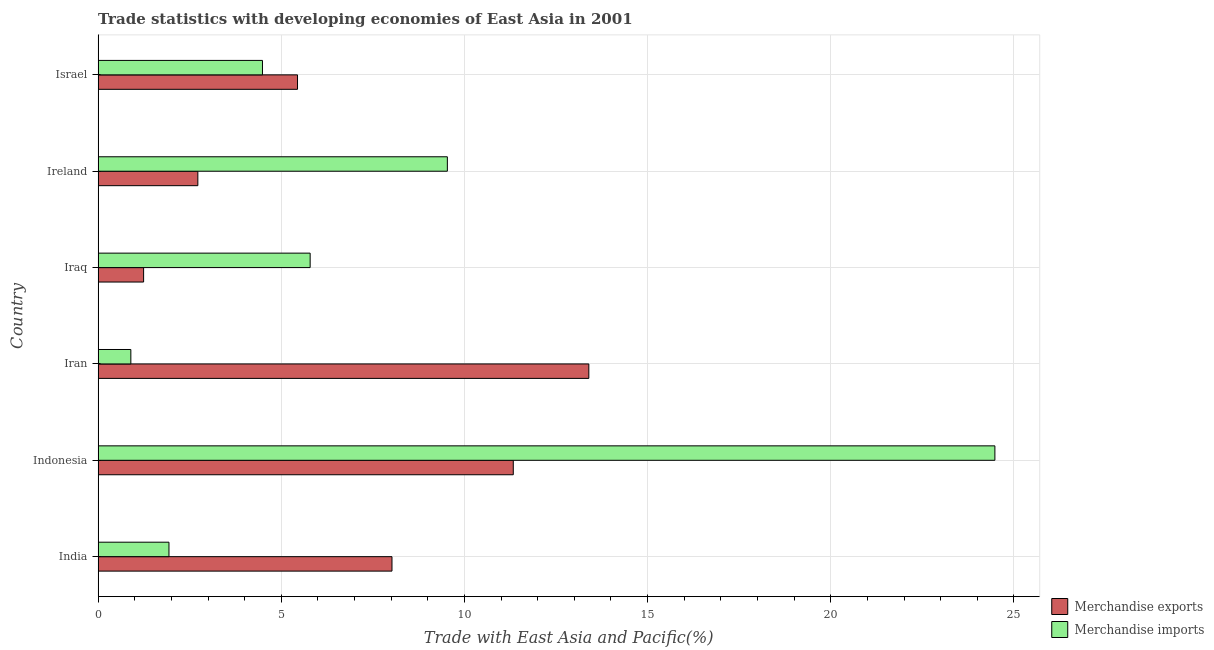How many different coloured bars are there?
Keep it short and to the point. 2. Are the number of bars per tick equal to the number of legend labels?
Offer a terse response. Yes. Are the number of bars on each tick of the Y-axis equal?
Provide a short and direct response. Yes. How many bars are there on the 6th tick from the bottom?
Provide a succinct answer. 2. What is the merchandise exports in Indonesia?
Your answer should be compact. 11.33. Across all countries, what is the maximum merchandise imports?
Offer a terse response. 24.48. Across all countries, what is the minimum merchandise exports?
Your response must be concise. 1.24. In which country was the merchandise exports minimum?
Your answer should be very brief. Iraq. What is the total merchandise exports in the graph?
Your response must be concise. 42.16. What is the difference between the merchandise imports in India and that in Indonesia?
Give a very brief answer. -22.55. What is the difference between the merchandise exports in Iraq and the merchandise imports in India?
Your answer should be compact. -0.69. What is the average merchandise exports per country?
Your response must be concise. 7.03. What is the difference between the merchandise exports and merchandise imports in Ireland?
Your response must be concise. -6.81. In how many countries, is the merchandise exports greater than 9 %?
Provide a succinct answer. 2. What is the ratio of the merchandise imports in Iraq to that in Ireland?
Your answer should be compact. 0.61. Is the difference between the merchandise imports in Iran and Israel greater than the difference between the merchandise exports in Iran and Israel?
Offer a terse response. No. What is the difference between the highest and the second highest merchandise imports?
Give a very brief answer. 14.95. What is the difference between the highest and the lowest merchandise exports?
Provide a succinct answer. 12.15. Is the sum of the merchandise exports in Indonesia and Ireland greater than the maximum merchandise imports across all countries?
Your answer should be very brief. No. What does the 2nd bar from the top in Iraq represents?
Keep it short and to the point. Merchandise exports. What does the 2nd bar from the bottom in Iran represents?
Provide a short and direct response. Merchandise imports. Are all the bars in the graph horizontal?
Your response must be concise. Yes. Are the values on the major ticks of X-axis written in scientific E-notation?
Ensure brevity in your answer.  No. Does the graph contain any zero values?
Make the answer very short. No. Does the graph contain grids?
Provide a short and direct response. Yes. Where does the legend appear in the graph?
Your answer should be compact. Bottom right. What is the title of the graph?
Your answer should be compact. Trade statistics with developing economies of East Asia in 2001. Does "current US$" appear as one of the legend labels in the graph?
Keep it short and to the point. No. What is the label or title of the X-axis?
Ensure brevity in your answer.  Trade with East Asia and Pacific(%). What is the Trade with East Asia and Pacific(%) of Merchandise exports in India?
Keep it short and to the point. 8.02. What is the Trade with East Asia and Pacific(%) in Merchandise imports in India?
Give a very brief answer. 1.93. What is the Trade with East Asia and Pacific(%) of Merchandise exports in Indonesia?
Keep it short and to the point. 11.33. What is the Trade with East Asia and Pacific(%) of Merchandise imports in Indonesia?
Your answer should be very brief. 24.48. What is the Trade with East Asia and Pacific(%) of Merchandise exports in Iran?
Your answer should be compact. 13.4. What is the Trade with East Asia and Pacific(%) of Merchandise imports in Iran?
Ensure brevity in your answer.  0.89. What is the Trade with East Asia and Pacific(%) of Merchandise exports in Iraq?
Ensure brevity in your answer.  1.24. What is the Trade with East Asia and Pacific(%) of Merchandise imports in Iraq?
Your answer should be very brief. 5.79. What is the Trade with East Asia and Pacific(%) in Merchandise exports in Ireland?
Offer a very short reply. 2.72. What is the Trade with East Asia and Pacific(%) in Merchandise imports in Ireland?
Your answer should be compact. 9.53. What is the Trade with East Asia and Pacific(%) of Merchandise exports in Israel?
Your answer should be compact. 5.44. What is the Trade with East Asia and Pacific(%) of Merchandise imports in Israel?
Your answer should be compact. 4.49. Across all countries, what is the maximum Trade with East Asia and Pacific(%) of Merchandise exports?
Keep it short and to the point. 13.4. Across all countries, what is the maximum Trade with East Asia and Pacific(%) of Merchandise imports?
Give a very brief answer. 24.48. Across all countries, what is the minimum Trade with East Asia and Pacific(%) of Merchandise exports?
Provide a succinct answer. 1.24. Across all countries, what is the minimum Trade with East Asia and Pacific(%) of Merchandise imports?
Offer a very short reply. 0.89. What is the total Trade with East Asia and Pacific(%) of Merchandise exports in the graph?
Give a very brief answer. 42.16. What is the total Trade with East Asia and Pacific(%) of Merchandise imports in the graph?
Offer a terse response. 47.12. What is the difference between the Trade with East Asia and Pacific(%) in Merchandise exports in India and that in Indonesia?
Provide a succinct answer. -3.31. What is the difference between the Trade with East Asia and Pacific(%) in Merchandise imports in India and that in Indonesia?
Provide a succinct answer. -22.55. What is the difference between the Trade with East Asia and Pacific(%) of Merchandise exports in India and that in Iran?
Your answer should be compact. -5.37. What is the difference between the Trade with East Asia and Pacific(%) of Merchandise imports in India and that in Iran?
Your answer should be compact. 1.04. What is the difference between the Trade with East Asia and Pacific(%) in Merchandise exports in India and that in Iraq?
Your response must be concise. 6.78. What is the difference between the Trade with East Asia and Pacific(%) in Merchandise imports in India and that in Iraq?
Give a very brief answer. -3.85. What is the difference between the Trade with East Asia and Pacific(%) of Merchandise exports in India and that in Ireland?
Give a very brief answer. 5.3. What is the difference between the Trade with East Asia and Pacific(%) of Merchandise imports in India and that in Ireland?
Provide a short and direct response. -7.6. What is the difference between the Trade with East Asia and Pacific(%) of Merchandise exports in India and that in Israel?
Your response must be concise. 2.58. What is the difference between the Trade with East Asia and Pacific(%) in Merchandise imports in India and that in Israel?
Your response must be concise. -2.55. What is the difference between the Trade with East Asia and Pacific(%) in Merchandise exports in Indonesia and that in Iran?
Offer a very short reply. -2.06. What is the difference between the Trade with East Asia and Pacific(%) in Merchandise imports in Indonesia and that in Iran?
Your response must be concise. 23.59. What is the difference between the Trade with East Asia and Pacific(%) of Merchandise exports in Indonesia and that in Iraq?
Offer a very short reply. 10.09. What is the difference between the Trade with East Asia and Pacific(%) of Merchandise imports in Indonesia and that in Iraq?
Your response must be concise. 18.69. What is the difference between the Trade with East Asia and Pacific(%) of Merchandise exports in Indonesia and that in Ireland?
Provide a succinct answer. 8.61. What is the difference between the Trade with East Asia and Pacific(%) in Merchandise imports in Indonesia and that in Ireland?
Provide a short and direct response. 14.95. What is the difference between the Trade with East Asia and Pacific(%) in Merchandise exports in Indonesia and that in Israel?
Your answer should be very brief. 5.89. What is the difference between the Trade with East Asia and Pacific(%) of Merchandise imports in Indonesia and that in Israel?
Offer a very short reply. 19.99. What is the difference between the Trade with East Asia and Pacific(%) in Merchandise exports in Iran and that in Iraq?
Your answer should be very brief. 12.15. What is the difference between the Trade with East Asia and Pacific(%) of Merchandise imports in Iran and that in Iraq?
Provide a succinct answer. -4.9. What is the difference between the Trade with East Asia and Pacific(%) of Merchandise exports in Iran and that in Ireland?
Provide a succinct answer. 10.67. What is the difference between the Trade with East Asia and Pacific(%) of Merchandise imports in Iran and that in Ireland?
Offer a very short reply. -8.64. What is the difference between the Trade with East Asia and Pacific(%) of Merchandise exports in Iran and that in Israel?
Provide a succinct answer. 7.95. What is the difference between the Trade with East Asia and Pacific(%) in Merchandise imports in Iran and that in Israel?
Offer a very short reply. -3.59. What is the difference between the Trade with East Asia and Pacific(%) in Merchandise exports in Iraq and that in Ireland?
Your response must be concise. -1.48. What is the difference between the Trade with East Asia and Pacific(%) of Merchandise imports in Iraq and that in Ireland?
Give a very brief answer. -3.75. What is the difference between the Trade with East Asia and Pacific(%) of Merchandise exports in Iraq and that in Israel?
Your answer should be very brief. -4.2. What is the difference between the Trade with East Asia and Pacific(%) of Merchandise imports in Iraq and that in Israel?
Provide a succinct answer. 1.3. What is the difference between the Trade with East Asia and Pacific(%) in Merchandise exports in Ireland and that in Israel?
Offer a terse response. -2.72. What is the difference between the Trade with East Asia and Pacific(%) of Merchandise imports in Ireland and that in Israel?
Give a very brief answer. 5.05. What is the difference between the Trade with East Asia and Pacific(%) in Merchandise exports in India and the Trade with East Asia and Pacific(%) in Merchandise imports in Indonesia?
Your response must be concise. -16.46. What is the difference between the Trade with East Asia and Pacific(%) in Merchandise exports in India and the Trade with East Asia and Pacific(%) in Merchandise imports in Iran?
Provide a short and direct response. 7.13. What is the difference between the Trade with East Asia and Pacific(%) of Merchandise exports in India and the Trade with East Asia and Pacific(%) of Merchandise imports in Iraq?
Make the answer very short. 2.23. What is the difference between the Trade with East Asia and Pacific(%) of Merchandise exports in India and the Trade with East Asia and Pacific(%) of Merchandise imports in Ireland?
Ensure brevity in your answer.  -1.51. What is the difference between the Trade with East Asia and Pacific(%) in Merchandise exports in India and the Trade with East Asia and Pacific(%) in Merchandise imports in Israel?
Give a very brief answer. 3.54. What is the difference between the Trade with East Asia and Pacific(%) of Merchandise exports in Indonesia and the Trade with East Asia and Pacific(%) of Merchandise imports in Iran?
Provide a short and direct response. 10.44. What is the difference between the Trade with East Asia and Pacific(%) in Merchandise exports in Indonesia and the Trade with East Asia and Pacific(%) in Merchandise imports in Iraq?
Make the answer very short. 5.54. What is the difference between the Trade with East Asia and Pacific(%) in Merchandise exports in Indonesia and the Trade with East Asia and Pacific(%) in Merchandise imports in Ireland?
Ensure brevity in your answer.  1.8. What is the difference between the Trade with East Asia and Pacific(%) of Merchandise exports in Indonesia and the Trade with East Asia and Pacific(%) of Merchandise imports in Israel?
Provide a succinct answer. 6.85. What is the difference between the Trade with East Asia and Pacific(%) of Merchandise exports in Iran and the Trade with East Asia and Pacific(%) of Merchandise imports in Iraq?
Ensure brevity in your answer.  7.61. What is the difference between the Trade with East Asia and Pacific(%) of Merchandise exports in Iran and the Trade with East Asia and Pacific(%) of Merchandise imports in Ireland?
Your answer should be very brief. 3.86. What is the difference between the Trade with East Asia and Pacific(%) in Merchandise exports in Iran and the Trade with East Asia and Pacific(%) in Merchandise imports in Israel?
Give a very brief answer. 8.91. What is the difference between the Trade with East Asia and Pacific(%) in Merchandise exports in Iraq and the Trade with East Asia and Pacific(%) in Merchandise imports in Ireland?
Your answer should be compact. -8.29. What is the difference between the Trade with East Asia and Pacific(%) of Merchandise exports in Iraq and the Trade with East Asia and Pacific(%) of Merchandise imports in Israel?
Offer a terse response. -3.24. What is the difference between the Trade with East Asia and Pacific(%) in Merchandise exports in Ireland and the Trade with East Asia and Pacific(%) in Merchandise imports in Israel?
Keep it short and to the point. -1.76. What is the average Trade with East Asia and Pacific(%) in Merchandise exports per country?
Provide a succinct answer. 7.03. What is the average Trade with East Asia and Pacific(%) in Merchandise imports per country?
Give a very brief answer. 7.85. What is the difference between the Trade with East Asia and Pacific(%) of Merchandise exports and Trade with East Asia and Pacific(%) of Merchandise imports in India?
Your answer should be very brief. 6.09. What is the difference between the Trade with East Asia and Pacific(%) of Merchandise exports and Trade with East Asia and Pacific(%) of Merchandise imports in Indonesia?
Offer a very short reply. -13.15. What is the difference between the Trade with East Asia and Pacific(%) in Merchandise exports and Trade with East Asia and Pacific(%) in Merchandise imports in Iran?
Keep it short and to the point. 12.5. What is the difference between the Trade with East Asia and Pacific(%) in Merchandise exports and Trade with East Asia and Pacific(%) in Merchandise imports in Iraq?
Offer a terse response. -4.55. What is the difference between the Trade with East Asia and Pacific(%) of Merchandise exports and Trade with East Asia and Pacific(%) of Merchandise imports in Ireland?
Offer a very short reply. -6.81. What is the difference between the Trade with East Asia and Pacific(%) of Merchandise exports and Trade with East Asia and Pacific(%) of Merchandise imports in Israel?
Make the answer very short. 0.96. What is the ratio of the Trade with East Asia and Pacific(%) in Merchandise exports in India to that in Indonesia?
Offer a terse response. 0.71. What is the ratio of the Trade with East Asia and Pacific(%) of Merchandise imports in India to that in Indonesia?
Your response must be concise. 0.08. What is the ratio of the Trade with East Asia and Pacific(%) of Merchandise exports in India to that in Iran?
Offer a very short reply. 0.6. What is the ratio of the Trade with East Asia and Pacific(%) in Merchandise imports in India to that in Iran?
Ensure brevity in your answer.  2.17. What is the ratio of the Trade with East Asia and Pacific(%) in Merchandise exports in India to that in Iraq?
Provide a succinct answer. 6.46. What is the ratio of the Trade with East Asia and Pacific(%) in Merchandise imports in India to that in Iraq?
Offer a terse response. 0.33. What is the ratio of the Trade with East Asia and Pacific(%) in Merchandise exports in India to that in Ireland?
Offer a very short reply. 2.95. What is the ratio of the Trade with East Asia and Pacific(%) in Merchandise imports in India to that in Ireland?
Ensure brevity in your answer.  0.2. What is the ratio of the Trade with East Asia and Pacific(%) of Merchandise exports in India to that in Israel?
Provide a succinct answer. 1.47. What is the ratio of the Trade with East Asia and Pacific(%) in Merchandise imports in India to that in Israel?
Your answer should be very brief. 0.43. What is the ratio of the Trade with East Asia and Pacific(%) of Merchandise exports in Indonesia to that in Iran?
Make the answer very short. 0.85. What is the ratio of the Trade with East Asia and Pacific(%) of Merchandise imports in Indonesia to that in Iran?
Ensure brevity in your answer.  27.41. What is the ratio of the Trade with East Asia and Pacific(%) of Merchandise exports in Indonesia to that in Iraq?
Your answer should be compact. 9.13. What is the ratio of the Trade with East Asia and Pacific(%) in Merchandise imports in Indonesia to that in Iraq?
Your answer should be compact. 4.23. What is the ratio of the Trade with East Asia and Pacific(%) of Merchandise exports in Indonesia to that in Ireland?
Your answer should be compact. 4.16. What is the ratio of the Trade with East Asia and Pacific(%) of Merchandise imports in Indonesia to that in Ireland?
Your answer should be compact. 2.57. What is the ratio of the Trade with East Asia and Pacific(%) of Merchandise exports in Indonesia to that in Israel?
Your answer should be very brief. 2.08. What is the ratio of the Trade with East Asia and Pacific(%) of Merchandise imports in Indonesia to that in Israel?
Provide a succinct answer. 5.46. What is the ratio of the Trade with East Asia and Pacific(%) in Merchandise exports in Iran to that in Iraq?
Your answer should be very brief. 10.79. What is the ratio of the Trade with East Asia and Pacific(%) in Merchandise imports in Iran to that in Iraq?
Your answer should be compact. 0.15. What is the ratio of the Trade with East Asia and Pacific(%) of Merchandise exports in Iran to that in Ireland?
Your response must be concise. 4.92. What is the ratio of the Trade with East Asia and Pacific(%) of Merchandise imports in Iran to that in Ireland?
Offer a terse response. 0.09. What is the ratio of the Trade with East Asia and Pacific(%) in Merchandise exports in Iran to that in Israel?
Offer a very short reply. 2.46. What is the ratio of the Trade with East Asia and Pacific(%) of Merchandise imports in Iran to that in Israel?
Your answer should be very brief. 0.2. What is the ratio of the Trade with East Asia and Pacific(%) in Merchandise exports in Iraq to that in Ireland?
Your answer should be compact. 0.46. What is the ratio of the Trade with East Asia and Pacific(%) of Merchandise imports in Iraq to that in Ireland?
Offer a very short reply. 0.61. What is the ratio of the Trade with East Asia and Pacific(%) in Merchandise exports in Iraq to that in Israel?
Your answer should be very brief. 0.23. What is the ratio of the Trade with East Asia and Pacific(%) in Merchandise imports in Iraq to that in Israel?
Keep it short and to the point. 1.29. What is the ratio of the Trade with East Asia and Pacific(%) in Merchandise exports in Ireland to that in Israel?
Give a very brief answer. 0.5. What is the ratio of the Trade with East Asia and Pacific(%) of Merchandise imports in Ireland to that in Israel?
Your answer should be compact. 2.12. What is the difference between the highest and the second highest Trade with East Asia and Pacific(%) in Merchandise exports?
Offer a terse response. 2.06. What is the difference between the highest and the second highest Trade with East Asia and Pacific(%) in Merchandise imports?
Offer a very short reply. 14.95. What is the difference between the highest and the lowest Trade with East Asia and Pacific(%) in Merchandise exports?
Offer a very short reply. 12.15. What is the difference between the highest and the lowest Trade with East Asia and Pacific(%) of Merchandise imports?
Provide a succinct answer. 23.59. 